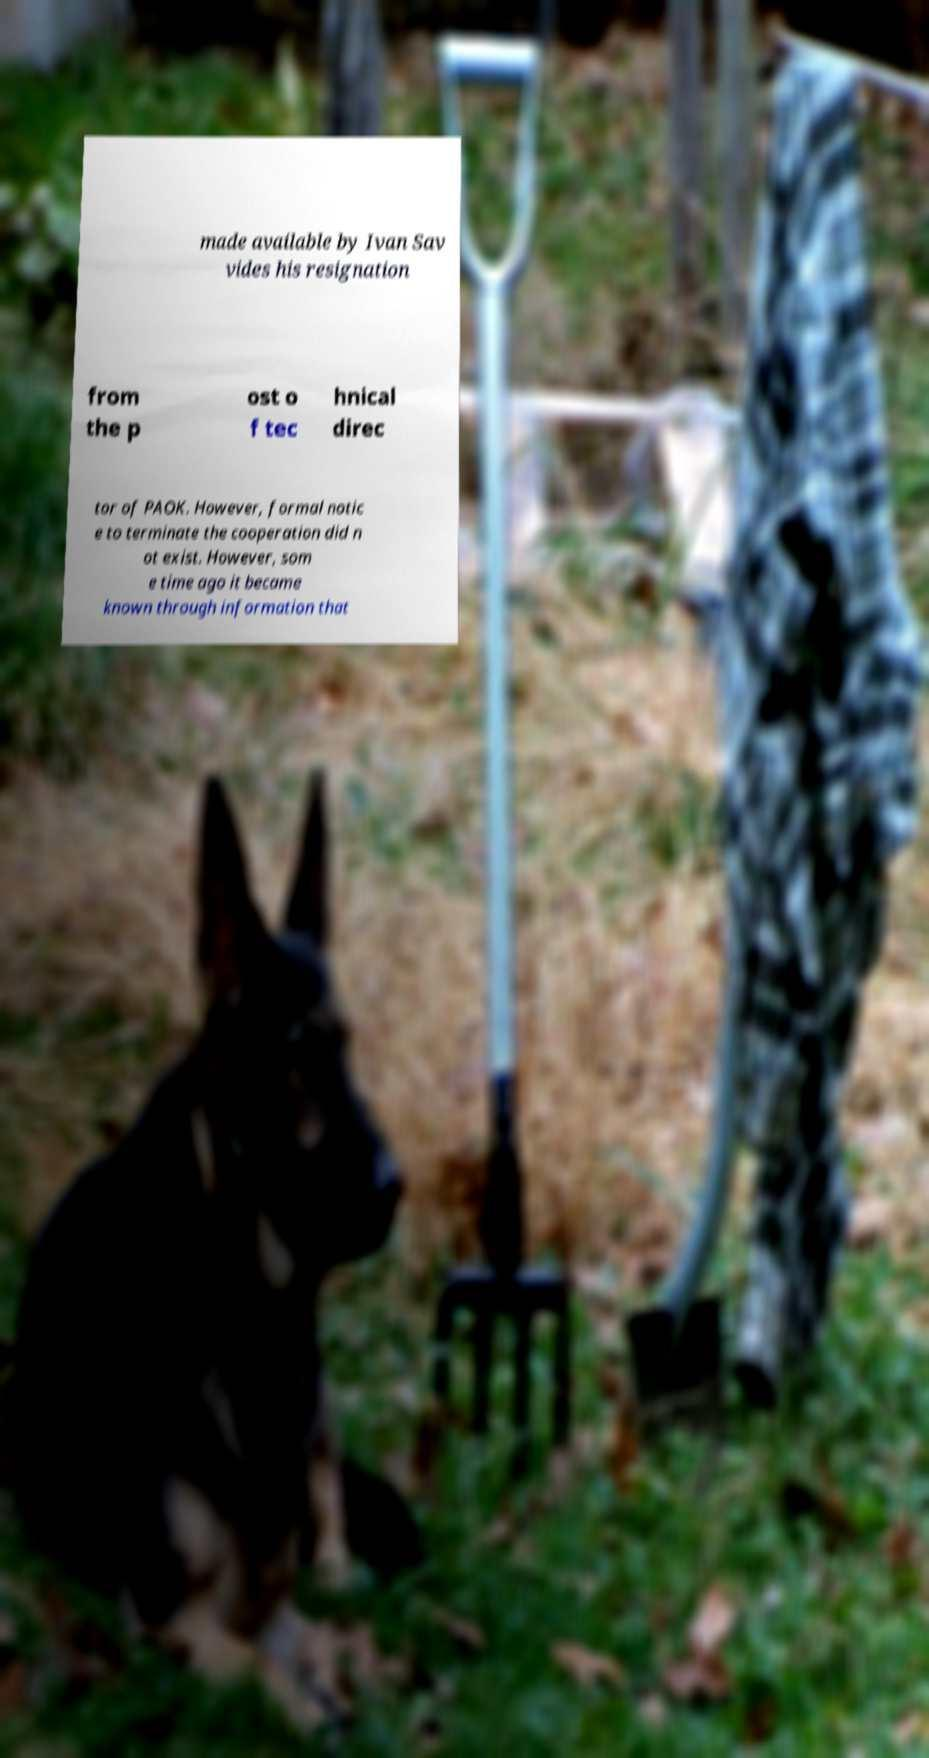Are there any symbolic meanings that can be inferred from the elements like the shovel and the dog next to the printed text? Symbolically, the shovel can represent work, digging, or excavation, either literally in a garden or metaphorically as digging for truth or information. Coupled with the German Shepherd, known for their protective nature, it might suggest a narrative of uncovering hidden truths while ensuring the information remains guarded or secure. This could reflect a deeper story of disclosure or discovery that the actual text might be hinting at. 